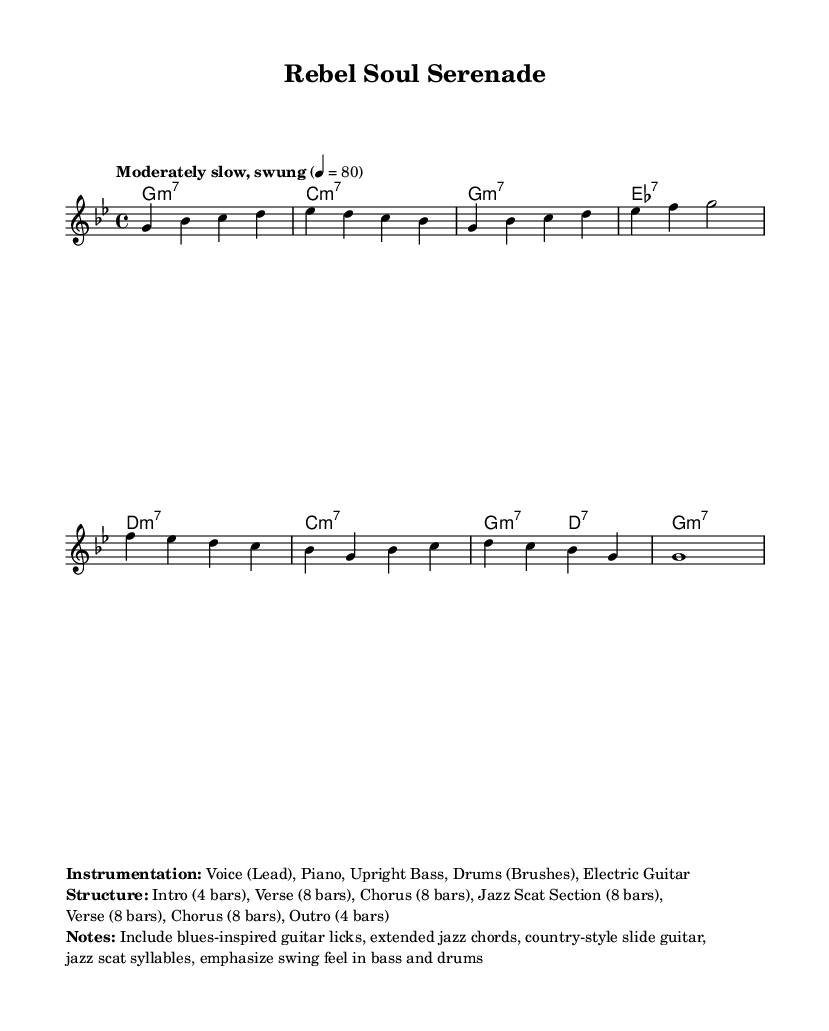What key is the piece in? The key signature is G minor, which is represented by the key signature that includes two flats.
Answer: G minor What is the time signature of the score? The time signature shown on the score is 4/4, indicating four beats per measure.
Answer: 4/4 What is the tempo marking? The tempo marking indicates a moderately slow, swung feel at 80 beats per minute.
Answer: Moderately slow, swung 80 How many bars are in the Intro? The score specifies that the Intro consists of 4 bars, as indicated in the structure section.
Answer: 4 bars What musical section comes after the Chorus? The structure outlines that a Jazz Scat Section follows the Chorus.
Answer: Jazz Scat Section How many bars are in the Chorus? The Chorus is noted to contain 8 bars, as mentioned in the provided structure summary.
Answer: 8 bars Which instruments are included in the instrumentation? The sheet mentions Voice (Lead), Piano, Upright Bass, Drums (Brushes), and Electric Guitar as part of the instrumentation.
Answer: Voice (Lead), Piano, Upright Bass, Drums (Brushes), Electric Guitar 